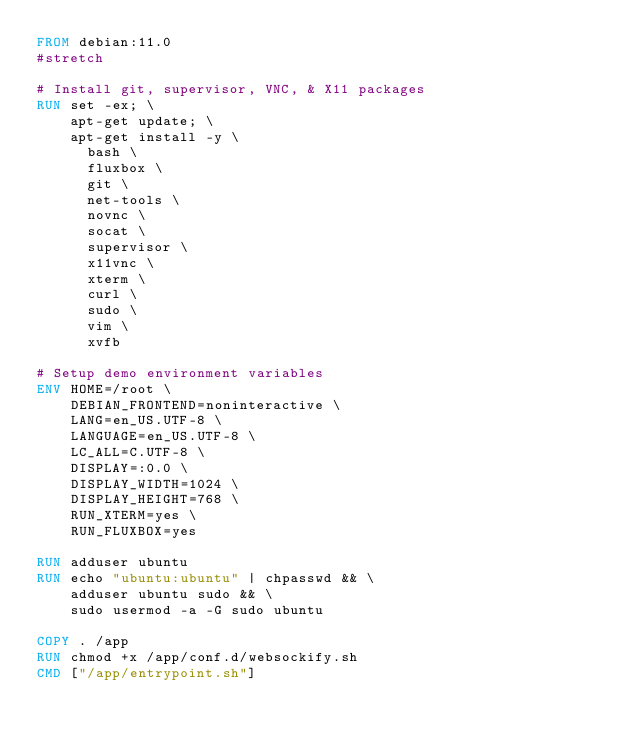<code> <loc_0><loc_0><loc_500><loc_500><_Dockerfile_>FROM debian:11.0
#stretch

# Install git, supervisor, VNC, & X11 packages
RUN set -ex; \
    apt-get update; \
    apt-get install -y \
      bash \
      fluxbox \
      git \
      net-tools \
      novnc \
      socat \
      supervisor \
      x11vnc \
      xterm \
      curl \
      sudo \
      vim \
      xvfb

# Setup demo environment variables
ENV HOME=/root \
    DEBIAN_FRONTEND=noninteractive \
    LANG=en_US.UTF-8 \
    LANGUAGE=en_US.UTF-8 \
    LC_ALL=C.UTF-8 \
    DISPLAY=:0.0 \
    DISPLAY_WIDTH=1024 \
    DISPLAY_HEIGHT=768 \
    RUN_XTERM=yes \
    RUN_FLUXBOX=yes

RUN adduser ubuntu
RUN echo "ubuntu:ubuntu" | chpasswd && \
    adduser ubuntu sudo && \
    sudo usermod -a -G sudo ubuntu
    
COPY . /app
RUN chmod +x /app/conf.d/websockify.sh
CMD ["/app/entrypoint.sh"]
</code> 